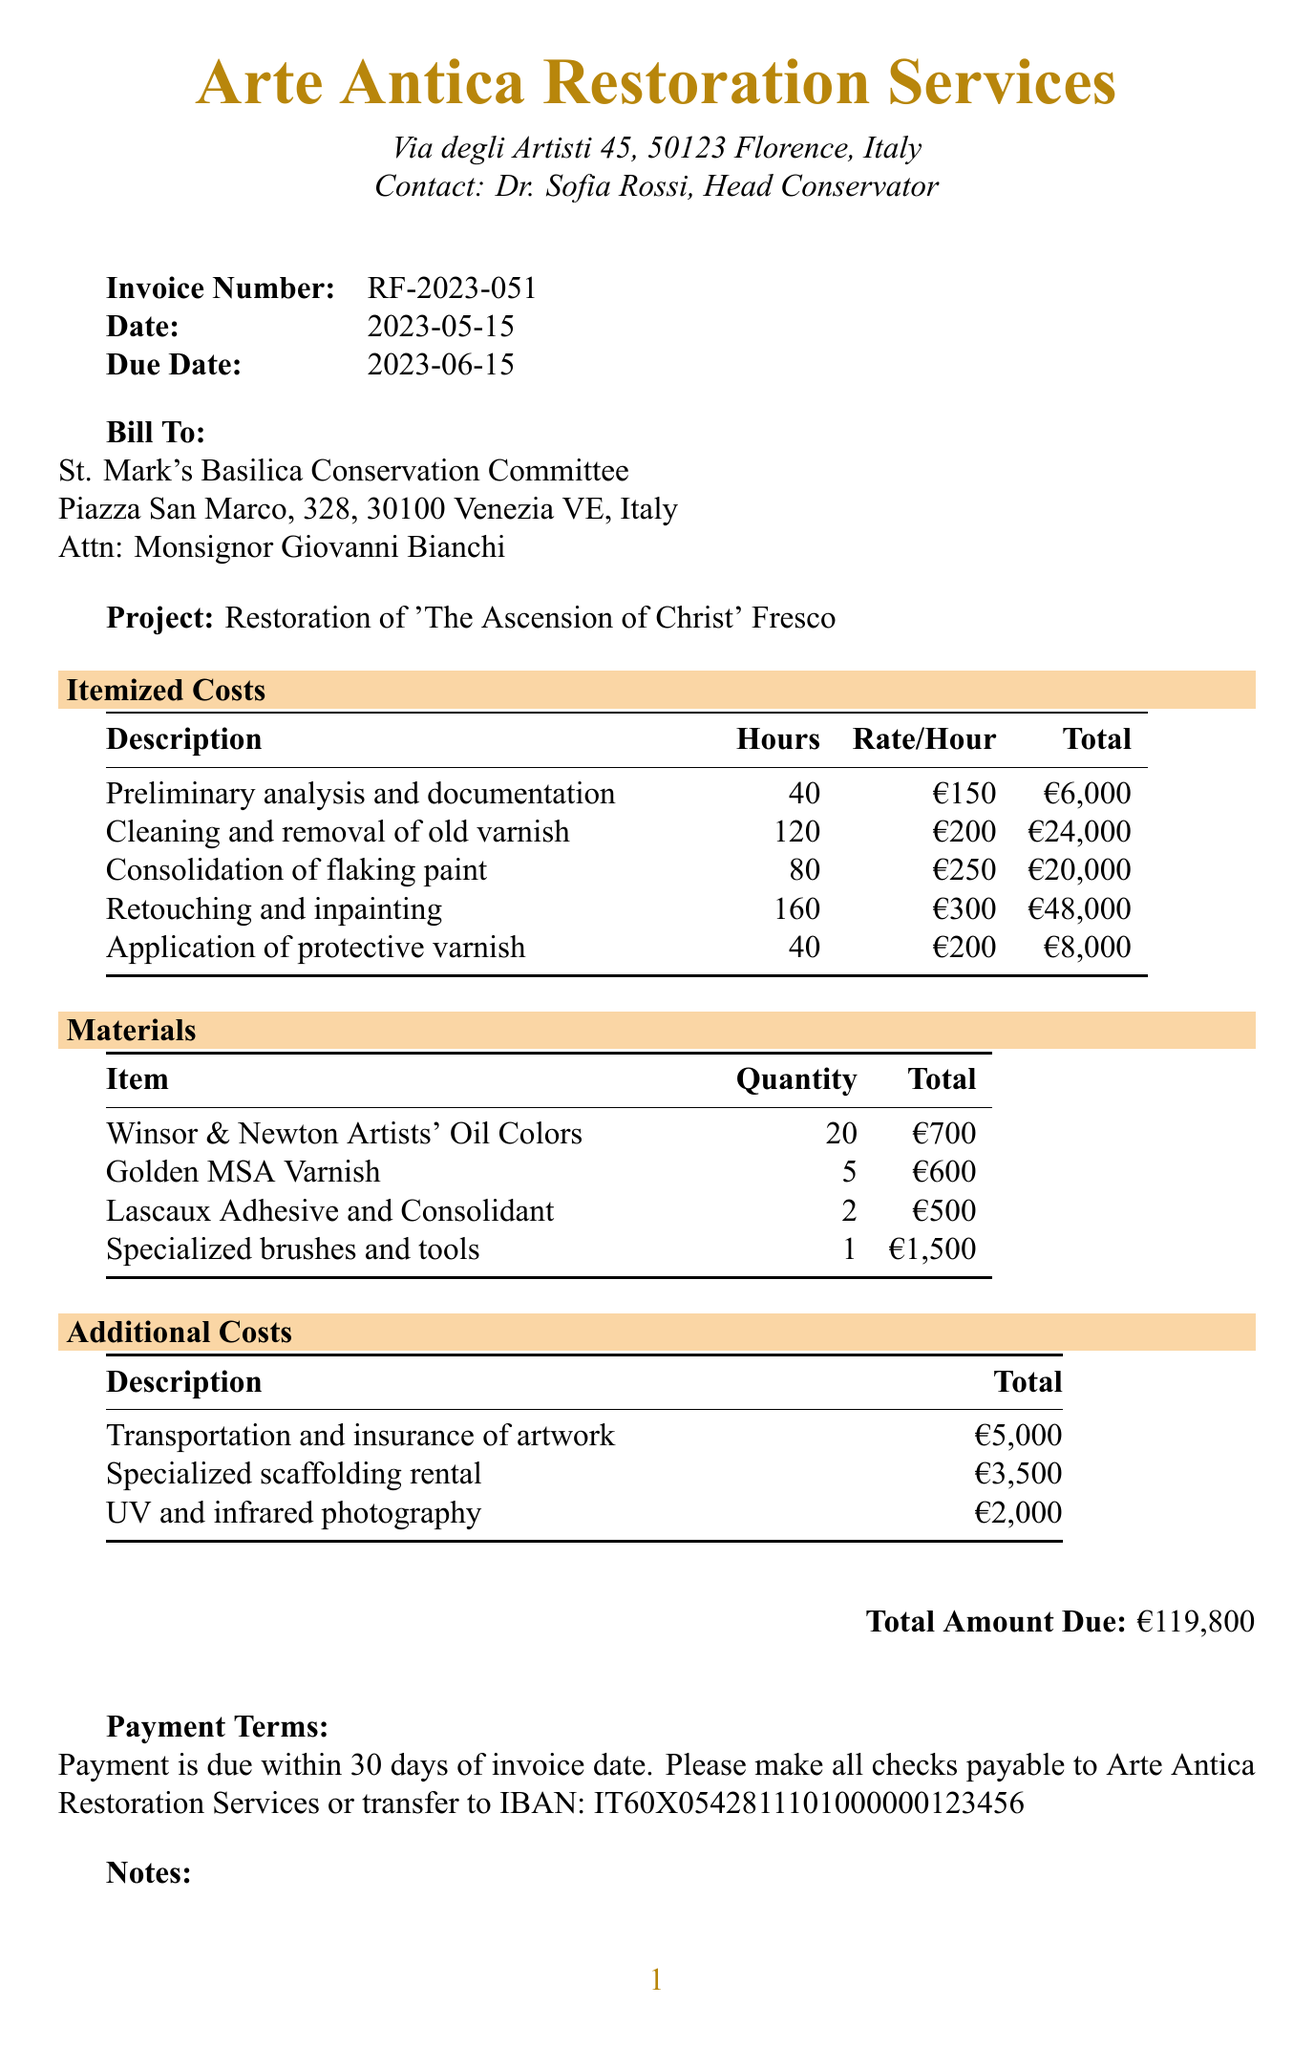What is the invoice number? The invoice number is provided in the document, specifically noted under "Invoice Number."
Answer: RF-2023-051 Who is the contact person for the client? The document lists a contact person for the client, found under "Bill To."
Answer: Monsignor Giovanni Bianchi What is the total amount due? The total amount due is stated clearly towards the end of the document.
Answer: €119,800 How many hours were spent on retouching and inpainting? This information is found in the itemized costs section, detailing the hours for each task.
Answer: 160 What is the unit price of the specialized brushes and tools? The price is mentioned in the materials section under the description of the specialty tools.
Answer: €1,500 What type of varnish is used in the restoration? The document specifies a particular type of varnish listed in the materials section.
Answer: Golden MSA Varnish How many items are available for materials? This refers to the number of different material items listed in the document, found in the materials section.
Answer: 4 What does the note about the restoration guidelines indicate? This note references compliance with specific guidelines, indicating adherence in the restoration process.
Answer: Italian Ministry of Cultural Heritage and Activities When is the payment due date? The due date for payment is provided in the document, noted clearly in the invoice details.
Answer: 2023-06-15 